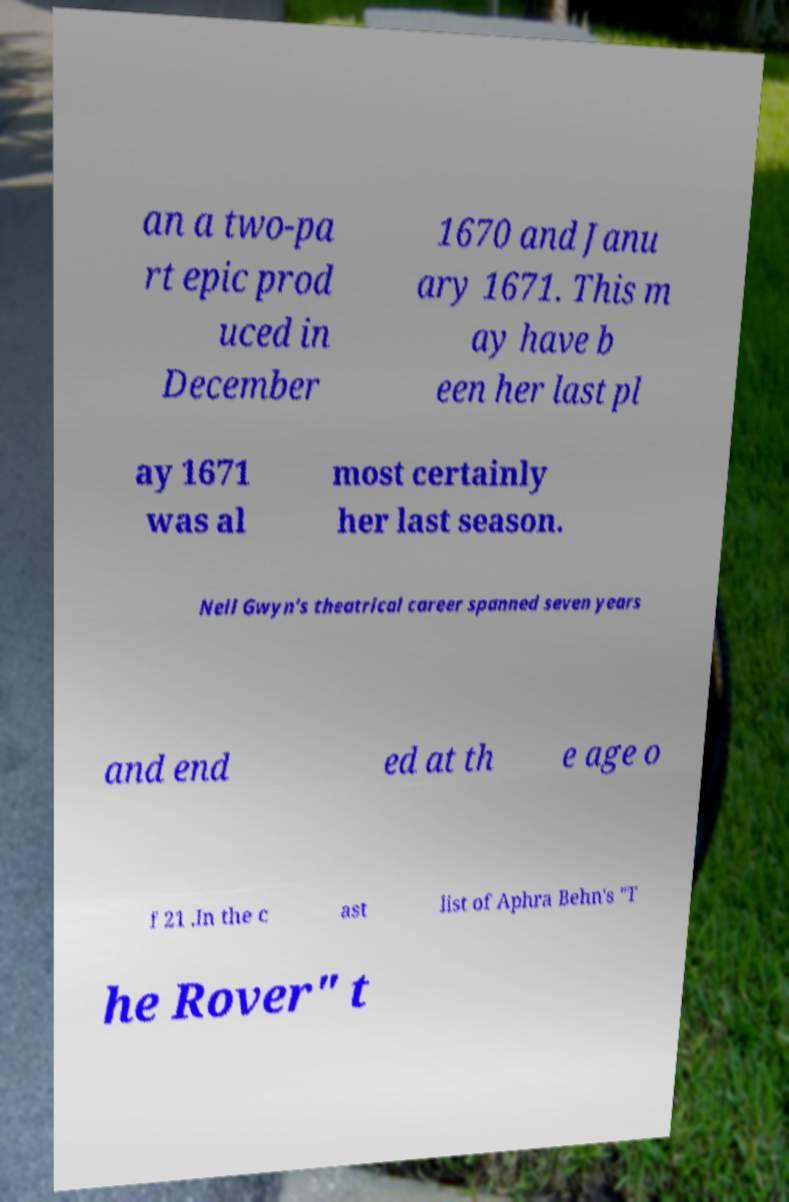Can you read and provide the text displayed in the image?This photo seems to have some interesting text. Can you extract and type it out for me? an a two-pa rt epic prod uced in December 1670 and Janu ary 1671. This m ay have b een her last pl ay 1671 was al most certainly her last season. Nell Gwyn's theatrical career spanned seven years and end ed at th e age o f 21 .In the c ast list of Aphra Behn's "T he Rover" t 